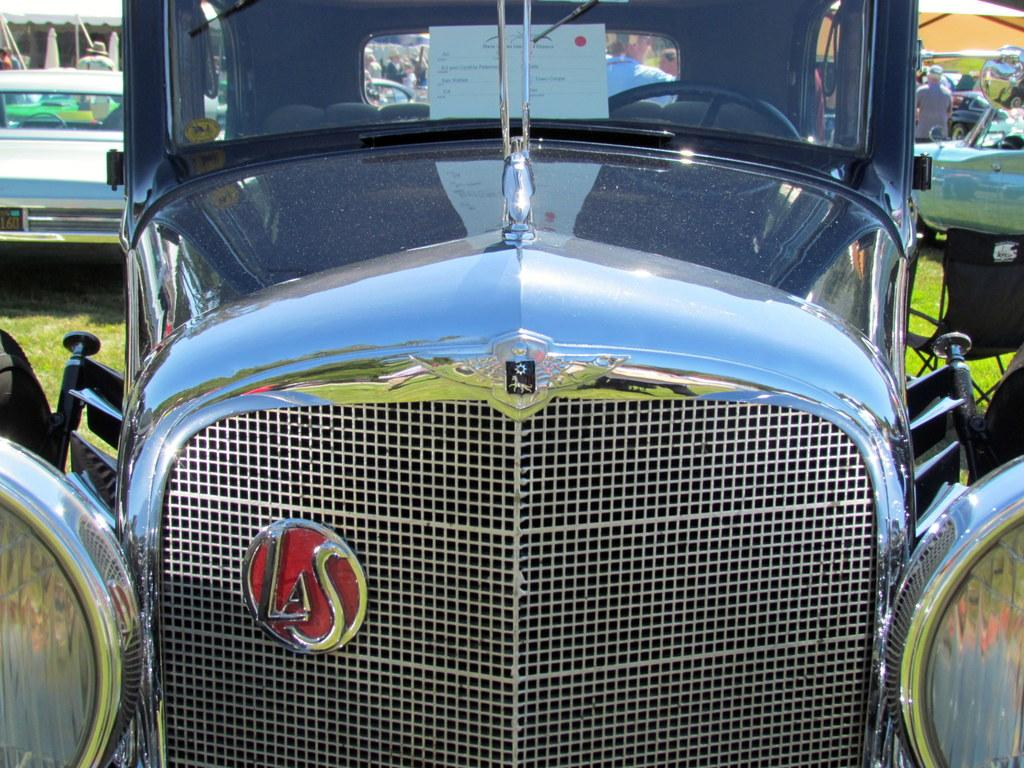What is unusual about the location of the cars in the image? The cars are on the grass in the image. What can be seen in the background of the image? There are tents and a group of people in the background of the image. How many frogs are sitting on the cars in the image? There are no frogs present in the image; it only features cars on the grass, tents, and a group of people in the background. 